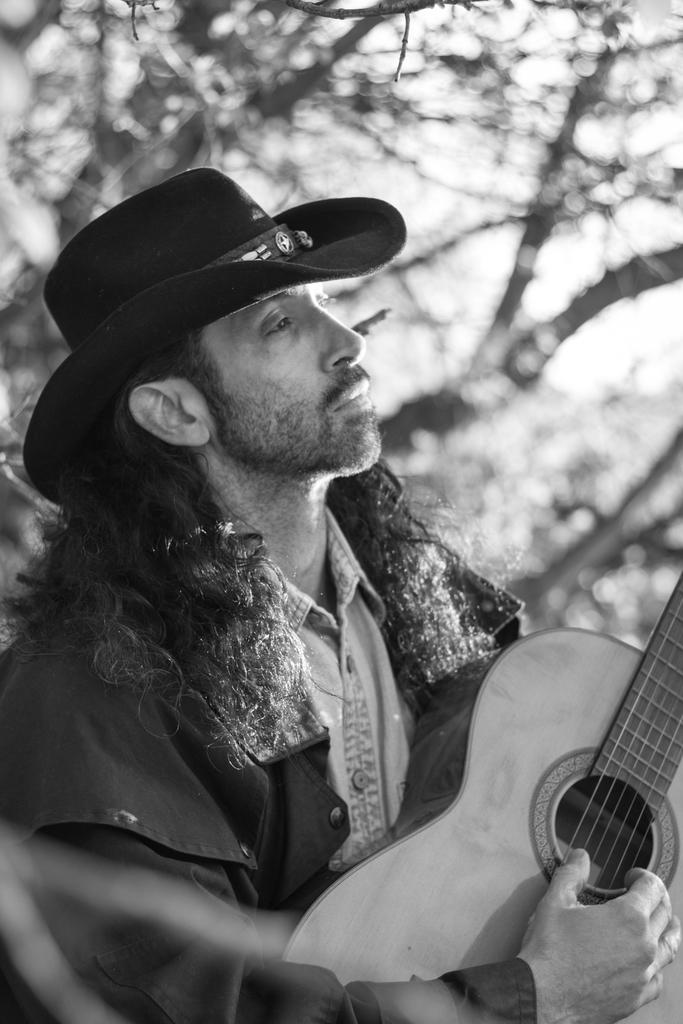What is the main subject of the image? There is a man in the image. What is the man doing in the image? The man is standing and playing a guitar. What can be seen in the background of the image? There are trees visible behind the man. What type of weather can be seen in the harbor in the image? There is no harbor present in the image, and therefore no weather can be observed in relation to it. 